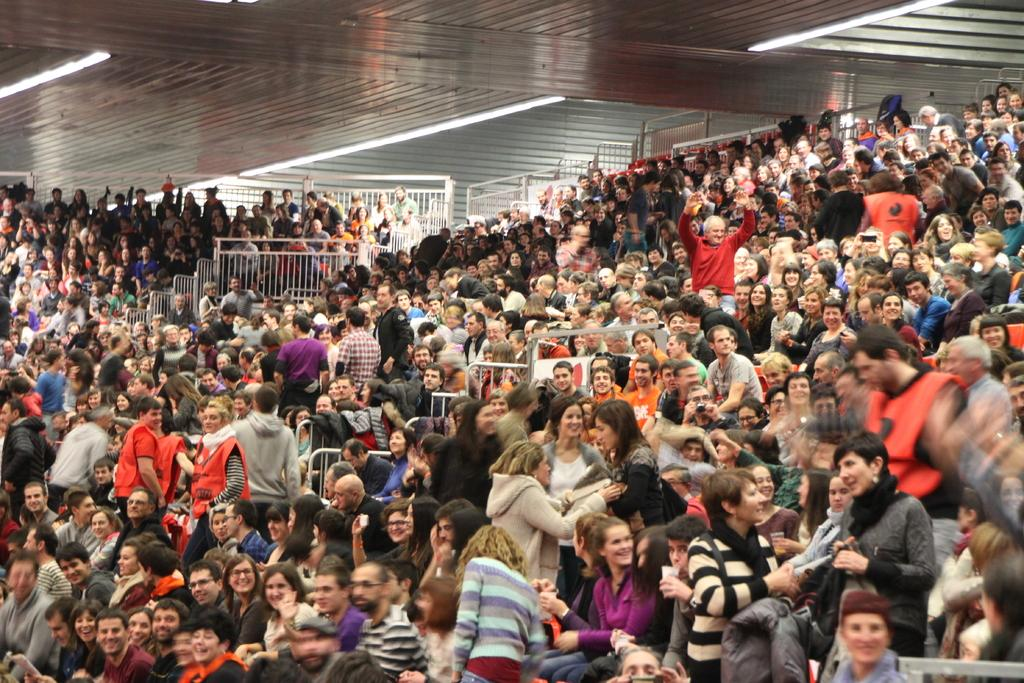How many people are in the group visible in the image? The number of people in the group cannot be determined from the provided facts. What can be seen near the group of people in the image? There are railings visible in the image. What is visible at the top of the image? There are lights visible at the top of the image. What type of shop can be seen in the image? There is no shop present in the image. How many toes are visible in the image? There is no reference to toes in the image, so it is not possible to answer that question. 